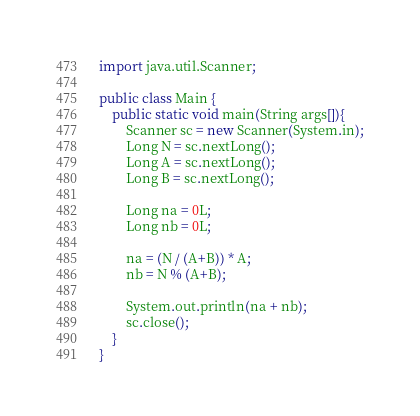<code> <loc_0><loc_0><loc_500><loc_500><_Java_>import java.util.Scanner;

public class Main {
	public static void main(String args[]){
		Scanner sc = new Scanner(System.in);
		Long N = sc.nextLong();
		Long A = sc.nextLong();
		Long B = sc.nextLong();

		Long na = 0L;
		Long nb = 0L;
		
		na = (N / (A+B)) * A;
		nb = N % (A+B);
		
		System.out.println(na + nb);
		sc.close();
	}
}</code> 